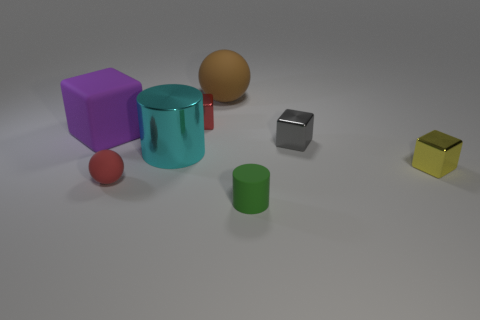Which object is the smallest? The smallest object appears to be the red sphere. Can you guess its purpose? Without context, it's hard to determine the exact purpose, but it might serve as a simple decorative item or could be part of a set for educational purposes, such as demonstrating geometry and colors. 